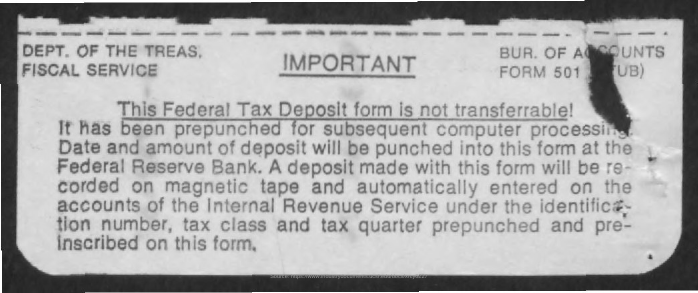Point out several critical features in this image. The Department of the Treasury's Fiscal Service is involved in the matter. 